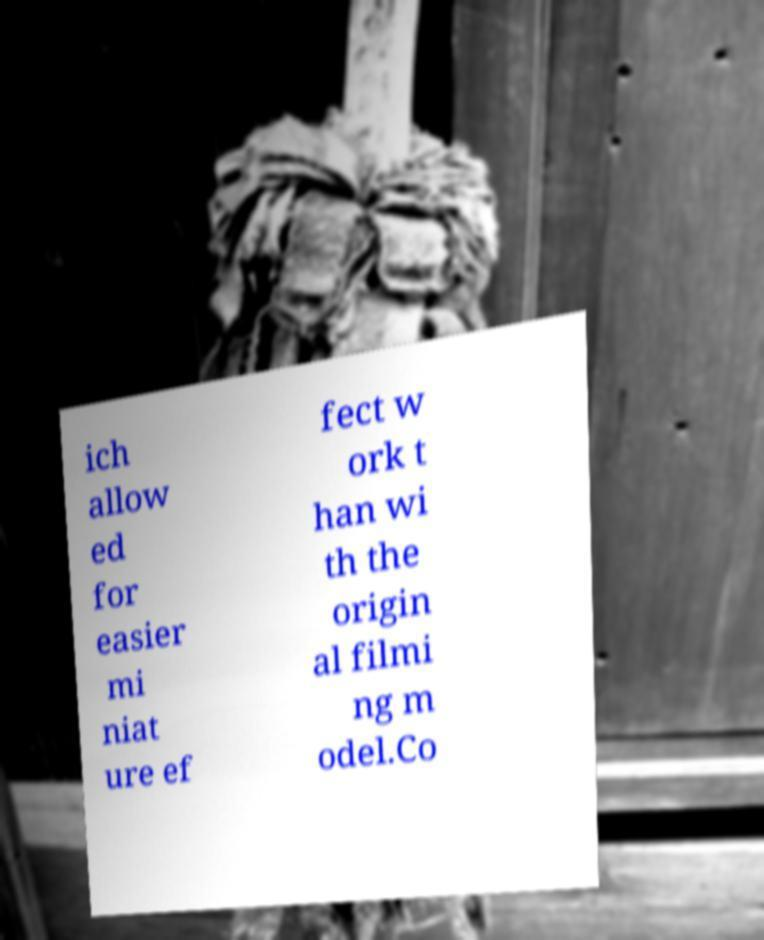Could you assist in decoding the text presented in this image and type it out clearly? ich allow ed for easier mi niat ure ef fect w ork t han wi th the origin al filmi ng m odel.Co 